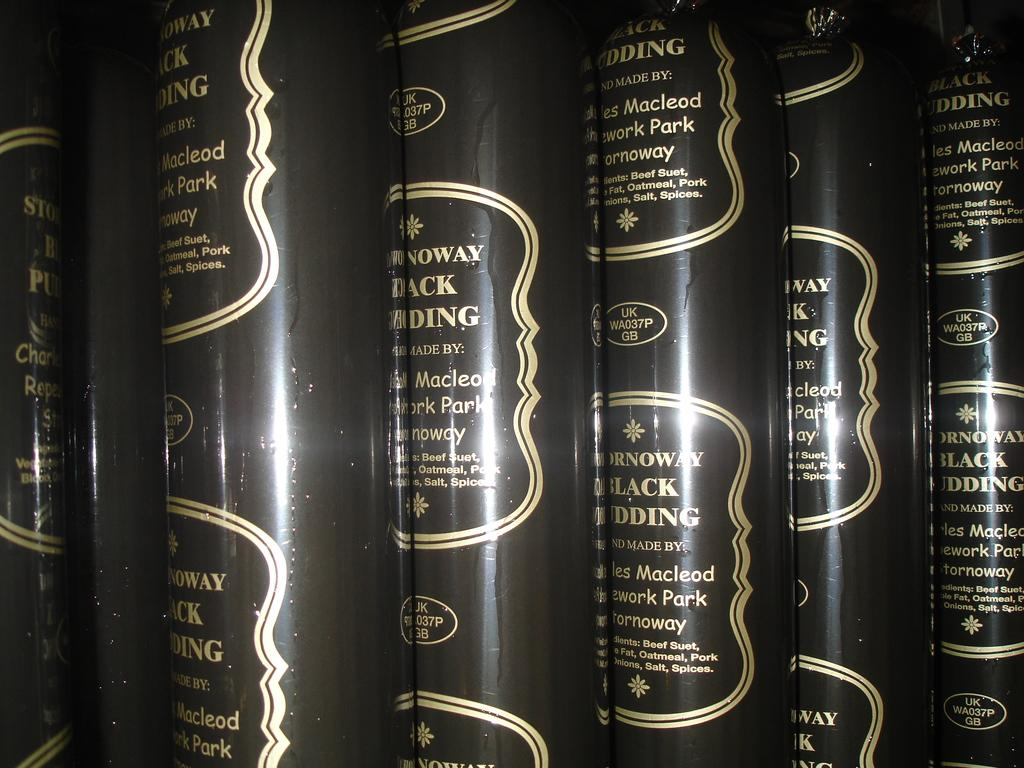<image>
Provide a brief description of the given image. Several identical items all say UK WA037P GB on them. 